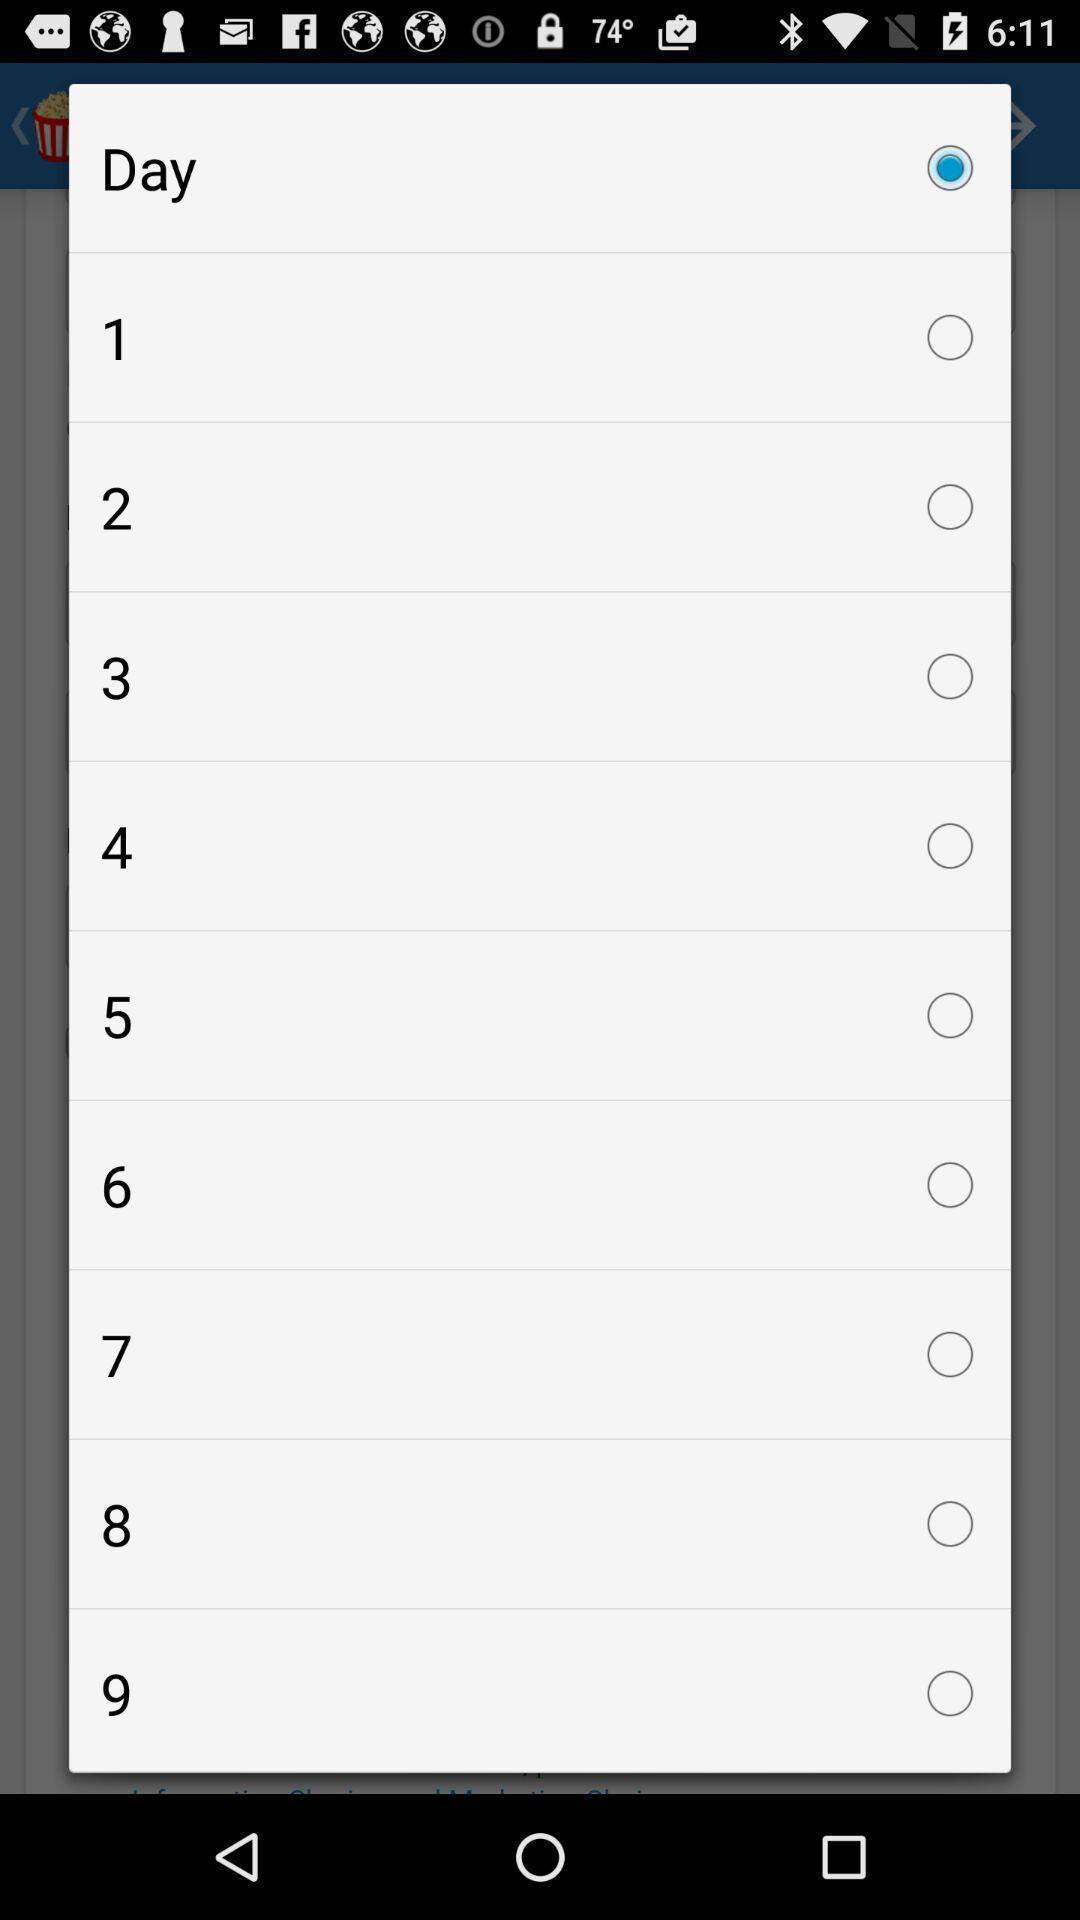Give me a summary of this screen capture. Pop-up displaying list of days. 